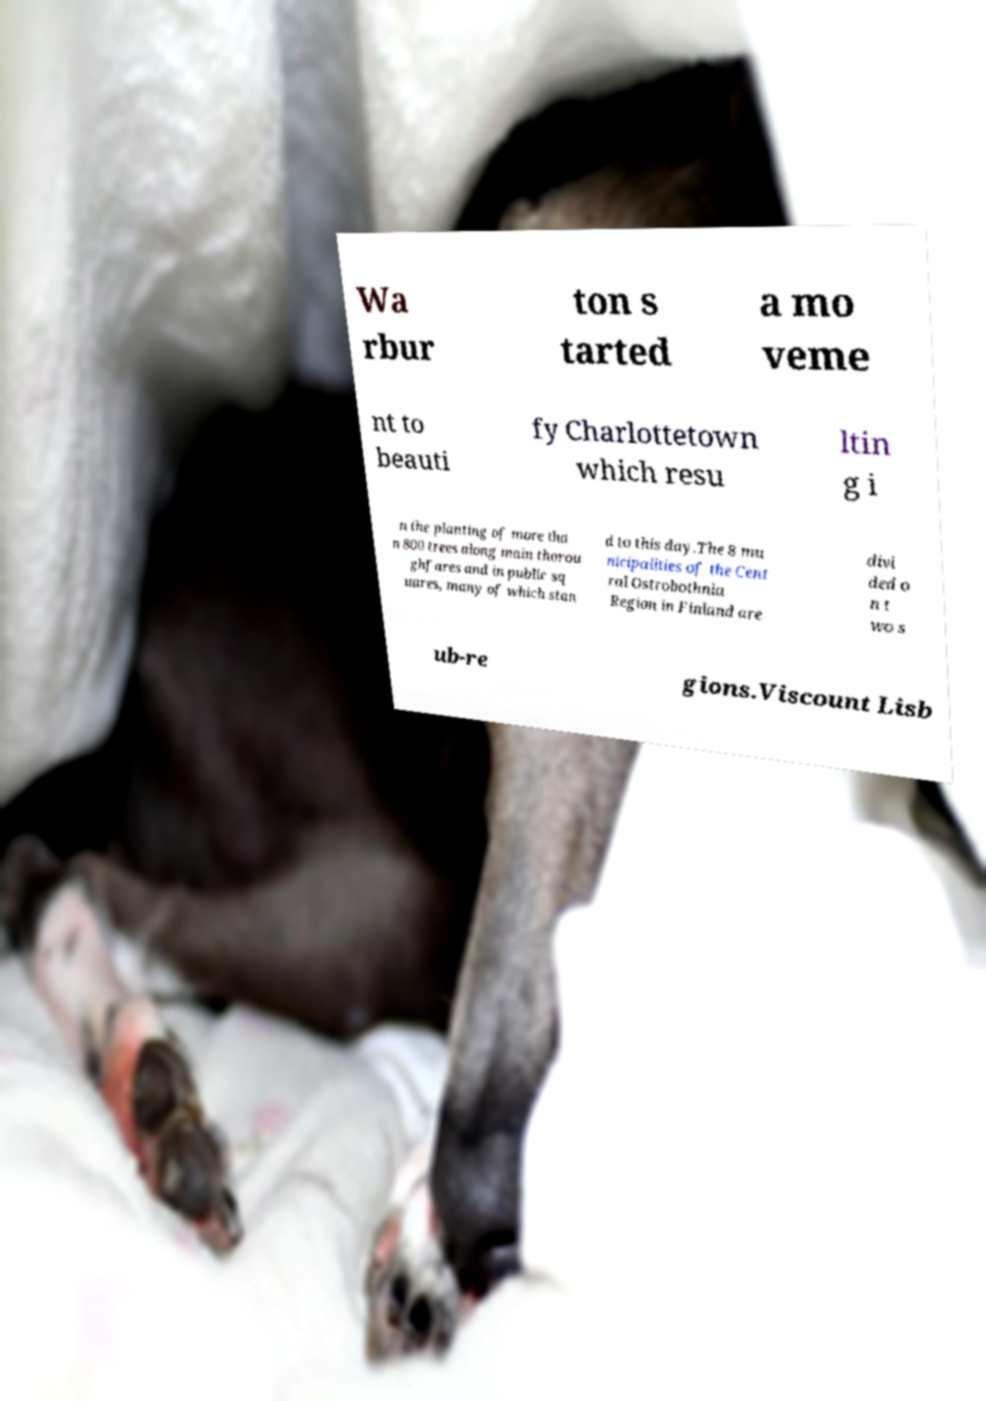Can you accurately transcribe the text from the provided image for me? Wa rbur ton s tarted a mo veme nt to beauti fy Charlottetown which resu ltin g i n the planting of more tha n 800 trees along main thorou ghfares and in public sq uares, many of which stan d to this day.The 8 mu nicipalities of the Cent ral Ostrobothnia Region in Finland are divi ded o n t wo s ub-re gions.Viscount Lisb 